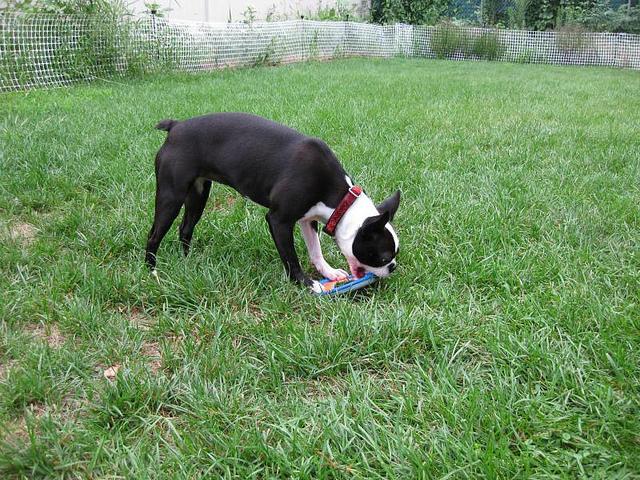What color is the dog?
Give a very brief answer. Black and white. What is the dog carrying?
Short answer required. Frisbee. What breed of dog is this?
Concise answer only. Pitbull. Is the dog eating grass?
Keep it brief. No. What color is the dog's neck?
Answer briefly. White. What is the breed of this dog?
Give a very brief answer. Bulldog. 